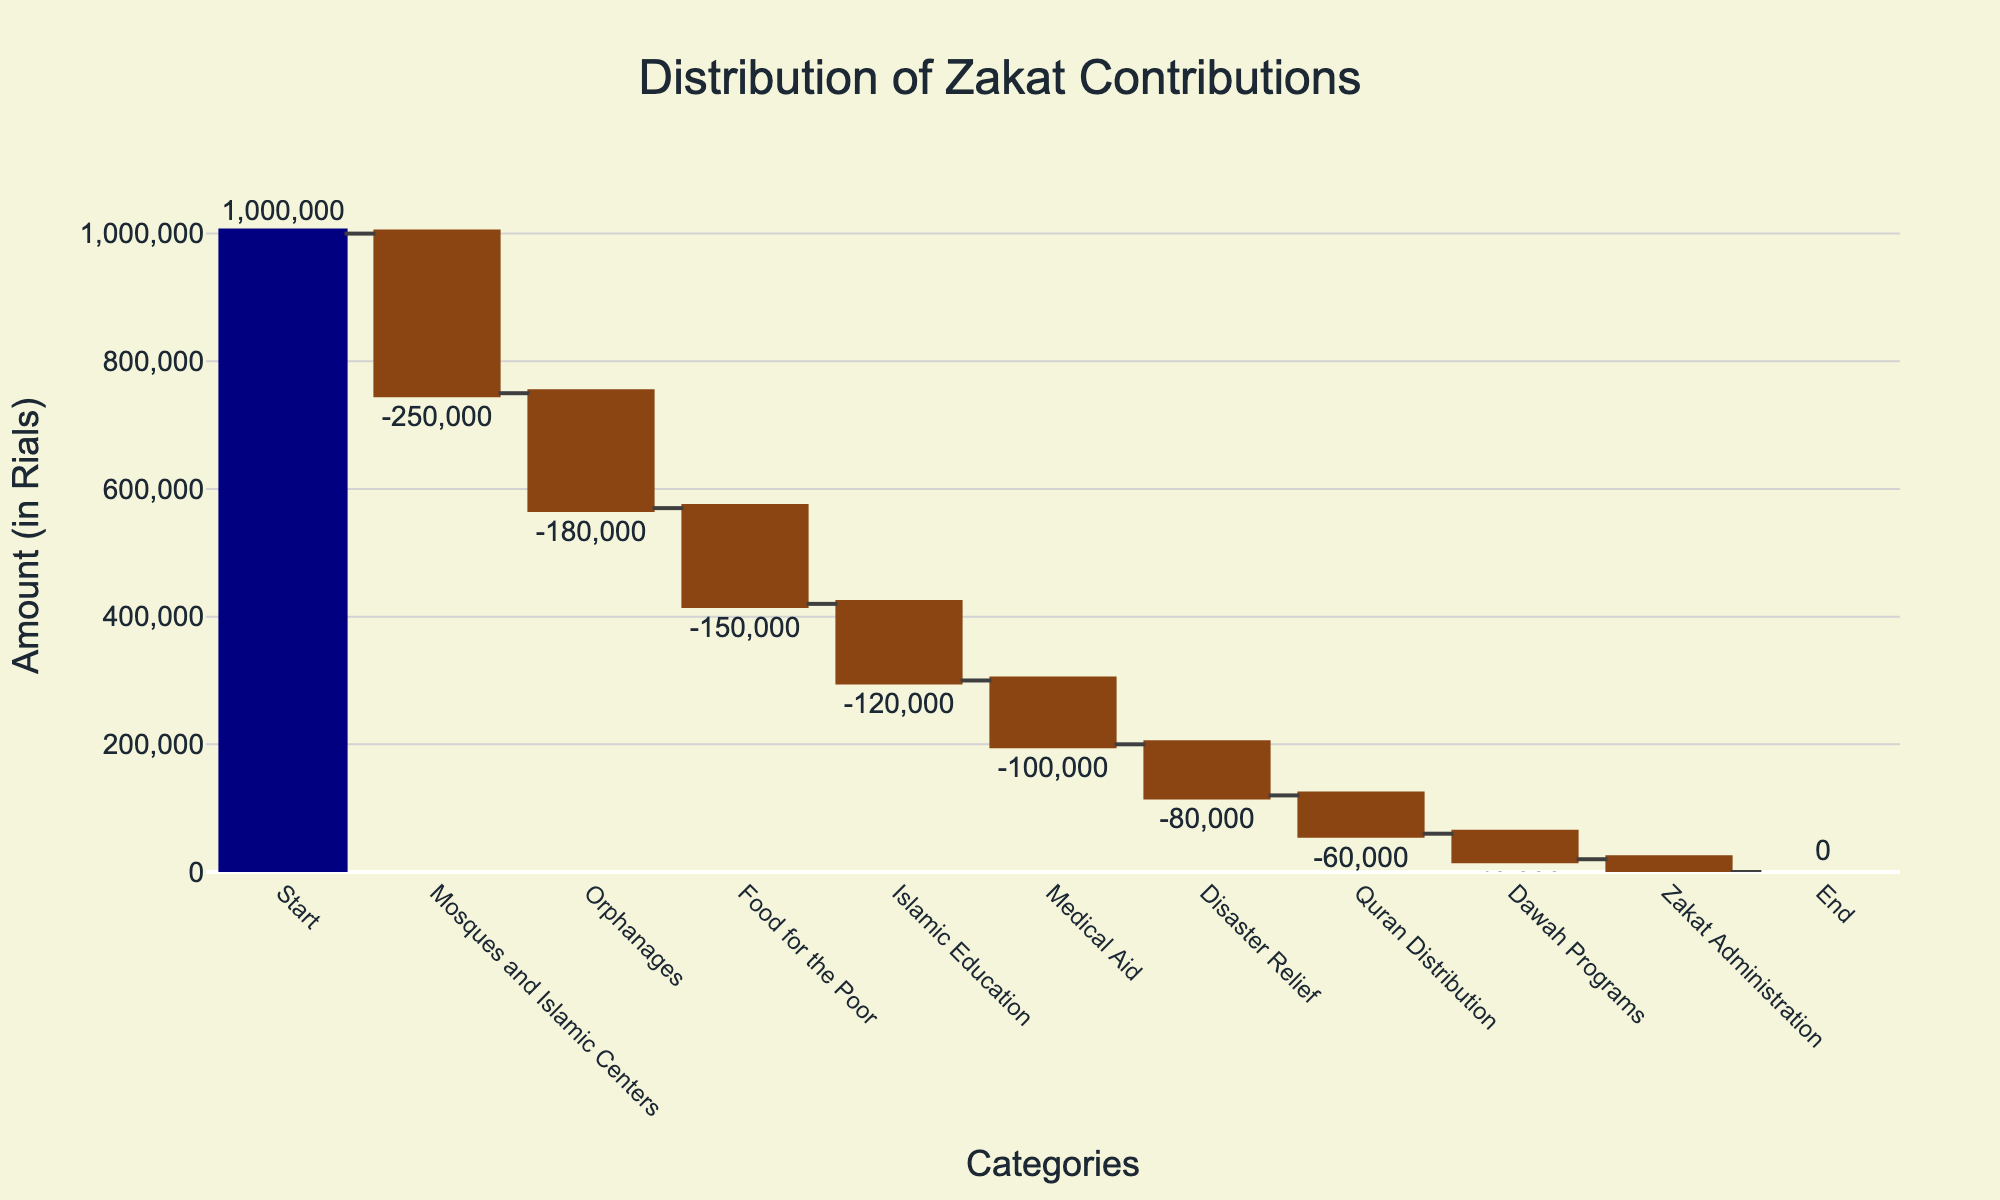What is the title of the figure? The title of a figure is typically displayed at the top of the plot. In this case, the title of the figure is "Distribution of Zakat Contributions".
Answer: Distribution of Zakat Contributions How much Zakat is allocated to Mosques and Islamic Centers? By looking at the bar labeled "Mosques and Islamic Centers", we can see its value marked, which is -250,000 Rials.
Answer: 250,000 Rials What is the total amount spent on Orphanages and Food for the Poor combined? To find the combined total, add the contributions for Orphanages (-180,000 Rials) and Food for the Poor (-150,000 Rials). -180,000 + -150,000 = -330,000. Therefore, the total amount is 330,000 Rials.
Answer: 330,000 Rials Which charitable cause has the smallest allocation and what is its value? Looking at the smallest bar and its corresponding label, Zakat Administration has the smallest value. The figure shows it as -20,000 Rials.
Answer: Zakat Administration, 20,000 Rials Which category has the second-highest allocation? By visually comparing the heights and values of the bars, the second-highest allocation after Mosques and Islamic Centers (-250,000 Rials) is Orphanages with -180,000 Rials.
Answer: Orphanages How much Zakat is allocated towards Quran Distribution and Dawah Programs together? Add the values for Quran Distribution (-60,000 Rials) and Dawah Programs (-40,000 Rials). -60,000 + -40,000 = -100,000. Therefore, the combined allocation is 100,000 Rials.
Answer: 100,000 Rials What remains as the final Zakat balance according to the chart? The final value or the "End" point in the waterfall chart shows the remaining Zakat balance after all allocations. The "End" point value is 0 Rials.
Answer: 0 Rials Compare the allocations for Medical Aid and Disaster Relief. Which one received more Zakat and by how much? Medical Aid has an allocation of -100,000 Rials, and Disaster Relief has -80,000 Rials. To find the difference, calculate 100,000 - 80,000 = 20,000. So, Medical Aid received 20,000 Rials more than Disaster Relief.
Answer: Medical Aid, by 20,000 Rials What is the total contribution made to Islamic Education, Medical Aid, and Disaster Relief? Sum the values for Islamic Education (-120,000 Rials), Medical Aid (-100,000 Rials), and Disaster Relief (-80,000 Rials). -120,000 + -100,000 + -80,000 = -300,000. The total contribution is therefore 300,000 Rials.
Answer: 300,000 Rials How many different charitable causes are shown in the chart? By counting the number of different categories labeled on the x-axis, excluding "Start" and "End", there are eight different charitable causes listed in the chart.
Answer: 8 